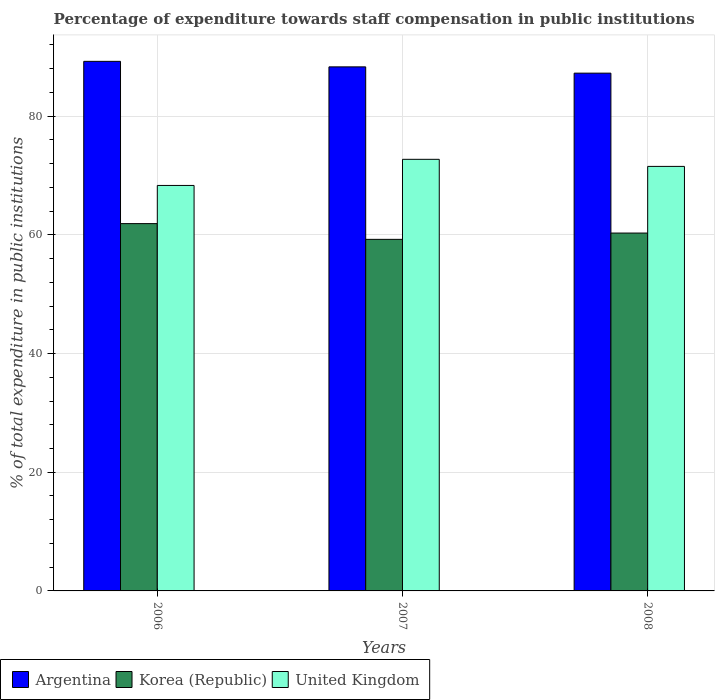Are the number of bars per tick equal to the number of legend labels?
Offer a very short reply. Yes. Are the number of bars on each tick of the X-axis equal?
Ensure brevity in your answer.  Yes. How many bars are there on the 3rd tick from the left?
Offer a terse response. 3. How many bars are there on the 2nd tick from the right?
Provide a succinct answer. 3. What is the label of the 1st group of bars from the left?
Provide a short and direct response. 2006. What is the percentage of expenditure towards staff compensation in Argentina in 2006?
Your response must be concise. 89.24. Across all years, what is the maximum percentage of expenditure towards staff compensation in United Kingdom?
Keep it short and to the point. 72.73. Across all years, what is the minimum percentage of expenditure towards staff compensation in Argentina?
Your answer should be very brief. 87.25. What is the total percentage of expenditure towards staff compensation in Argentina in the graph?
Your response must be concise. 264.81. What is the difference between the percentage of expenditure towards staff compensation in Argentina in 2006 and that in 2008?
Provide a short and direct response. 1.99. What is the difference between the percentage of expenditure towards staff compensation in United Kingdom in 2007 and the percentage of expenditure towards staff compensation in Argentina in 2006?
Provide a short and direct response. -16.51. What is the average percentage of expenditure towards staff compensation in United Kingdom per year?
Ensure brevity in your answer.  70.87. In the year 2006, what is the difference between the percentage of expenditure towards staff compensation in Argentina and percentage of expenditure towards staff compensation in United Kingdom?
Make the answer very short. 20.91. What is the ratio of the percentage of expenditure towards staff compensation in United Kingdom in 2007 to that in 2008?
Make the answer very short. 1.02. Is the percentage of expenditure towards staff compensation in United Kingdom in 2006 less than that in 2007?
Provide a succinct answer. Yes. Is the difference between the percentage of expenditure towards staff compensation in Argentina in 2006 and 2008 greater than the difference between the percentage of expenditure towards staff compensation in United Kingdom in 2006 and 2008?
Offer a very short reply. Yes. What is the difference between the highest and the second highest percentage of expenditure towards staff compensation in Argentina?
Make the answer very short. 0.93. What is the difference between the highest and the lowest percentage of expenditure towards staff compensation in United Kingdom?
Your answer should be very brief. 4.4. What does the 3rd bar from the left in 2007 represents?
Your answer should be compact. United Kingdom. What does the 3rd bar from the right in 2006 represents?
Ensure brevity in your answer.  Argentina. Is it the case that in every year, the sum of the percentage of expenditure towards staff compensation in Argentina and percentage of expenditure towards staff compensation in Korea (Republic) is greater than the percentage of expenditure towards staff compensation in United Kingdom?
Your response must be concise. Yes. How many bars are there?
Provide a short and direct response. 9. Are all the bars in the graph horizontal?
Your response must be concise. No. How many years are there in the graph?
Make the answer very short. 3. Are the values on the major ticks of Y-axis written in scientific E-notation?
Give a very brief answer. No. Does the graph contain any zero values?
Make the answer very short. No. How are the legend labels stacked?
Give a very brief answer. Horizontal. What is the title of the graph?
Offer a terse response. Percentage of expenditure towards staff compensation in public institutions. Does "Cabo Verde" appear as one of the legend labels in the graph?
Provide a succinct answer. No. What is the label or title of the Y-axis?
Your answer should be very brief. % of total expenditure in public institutions. What is the % of total expenditure in public institutions of Argentina in 2006?
Offer a very short reply. 89.24. What is the % of total expenditure in public institutions of Korea (Republic) in 2006?
Give a very brief answer. 61.9. What is the % of total expenditure in public institutions in United Kingdom in 2006?
Your response must be concise. 68.33. What is the % of total expenditure in public institutions of Argentina in 2007?
Offer a terse response. 88.31. What is the % of total expenditure in public institutions in Korea (Republic) in 2007?
Provide a succinct answer. 59.25. What is the % of total expenditure in public institutions in United Kingdom in 2007?
Ensure brevity in your answer.  72.73. What is the % of total expenditure in public institutions of Argentina in 2008?
Give a very brief answer. 87.25. What is the % of total expenditure in public institutions in Korea (Republic) in 2008?
Offer a terse response. 60.31. What is the % of total expenditure in public institutions of United Kingdom in 2008?
Ensure brevity in your answer.  71.54. Across all years, what is the maximum % of total expenditure in public institutions in Argentina?
Your answer should be compact. 89.24. Across all years, what is the maximum % of total expenditure in public institutions of Korea (Republic)?
Your response must be concise. 61.9. Across all years, what is the maximum % of total expenditure in public institutions of United Kingdom?
Give a very brief answer. 72.73. Across all years, what is the minimum % of total expenditure in public institutions in Argentina?
Offer a terse response. 87.25. Across all years, what is the minimum % of total expenditure in public institutions in Korea (Republic)?
Ensure brevity in your answer.  59.25. Across all years, what is the minimum % of total expenditure in public institutions in United Kingdom?
Your answer should be very brief. 68.33. What is the total % of total expenditure in public institutions in Argentina in the graph?
Make the answer very short. 264.81. What is the total % of total expenditure in public institutions of Korea (Republic) in the graph?
Keep it short and to the point. 181.45. What is the total % of total expenditure in public institutions in United Kingdom in the graph?
Make the answer very short. 212.6. What is the difference between the % of total expenditure in public institutions of Argentina in 2006 and that in 2007?
Ensure brevity in your answer.  0.93. What is the difference between the % of total expenditure in public institutions of Korea (Republic) in 2006 and that in 2007?
Keep it short and to the point. 2.65. What is the difference between the % of total expenditure in public institutions of United Kingdom in 2006 and that in 2007?
Keep it short and to the point. -4.4. What is the difference between the % of total expenditure in public institutions in Argentina in 2006 and that in 2008?
Give a very brief answer. 1.99. What is the difference between the % of total expenditure in public institutions of Korea (Republic) in 2006 and that in 2008?
Offer a terse response. 1.59. What is the difference between the % of total expenditure in public institutions of United Kingdom in 2006 and that in 2008?
Give a very brief answer. -3.21. What is the difference between the % of total expenditure in public institutions of Argentina in 2007 and that in 2008?
Your response must be concise. 1.06. What is the difference between the % of total expenditure in public institutions of Korea (Republic) in 2007 and that in 2008?
Provide a succinct answer. -1.06. What is the difference between the % of total expenditure in public institutions in United Kingdom in 2007 and that in 2008?
Give a very brief answer. 1.19. What is the difference between the % of total expenditure in public institutions in Argentina in 2006 and the % of total expenditure in public institutions in Korea (Republic) in 2007?
Your answer should be very brief. 30. What is the difference between the % of total expenditure in public institutions of Argentina in 2006 and the % of total expenditure in public institutions of United Kingdom in 2007?
Your answer should be compact. 16.51. What is the difference between the % of total expenditure in public institutions of Korea (Republic) in 2006 and the % of total expenditure in public institutions of United Kingdom in 2007?
Offer a terse response. -10.83. What is the difference between the % of total expenditure in public institutions of Argentina in 2006 and the % of total expenditure in public institutions of Korea (Republic) in 2008?
Keep it short and to the point. 28.93. What is the difference between the % of total expenditure in public institutions of Argentina in 2006 and the % of total expenditure in public institutions of United Kingdom in 2008?
Offer a very short reply. 17.7. What is the difference between the % of total expenditure in public institutions of Korea (Republic) in 2006 and the % of total expenditure in public institutions of United Kingdom in 2008?
Provide a short and direct response. -9.64. What is the difference between the % of total expenditure in public institutions of Argentina in 2007 and the % of total expenditure in public institutions of Korea (Republic) in 2008?
Keep it short and to the point. 28.01. What is the difference between the % of total expenditure in public institutions in Argentina in 2007 and the % of total expenditure in public institutions in United Kingdom in 2008?
Your answer should be very brief. 16.77. What is the difference between the % of total expenditure in public institutions in Korea (Republic) in 2007 and the % of total expenditure in public institutions in United Kingdom in 2008?
Make the answer very short. -12.3. What is the average % of total expenditure in public institutions of Argentina per year?
Your answer should be very brief. 88.27. What is the average % of total expenditure in public institutions of Korea (Republic) per year?
Provide a succinct answer. 60.48. What is the average % of total expenditure in public institutions in United Kingdom per year?
Ensure brevity in your answer.  70.87. In the year 2006, what is the difference between the % of total expenditure in public institutions in Argentina and % of total expenditure in public institutions in Korea (Republic)?
Give a very brief answer. 27.34. In the year 2006, what is the difference between the % of total expenditure in public institutions of Argentina and % of total expenditure in public institutions of United Kingdom?
Ensure brevity in your answer.  20.91. In the year 2006, what is the difference between the % of total expenditure in public institutions in Korea (Republic) and % of total expenditure in public institutions in United Kingdom?
Keep it short and to the point. -6.43. In the year 2007, what is the difference between the % of total expenditure in public institutions in Argentina and % of total expenditure in public institutions in Korea (Republic)?
Provide a succinct answer. 29.07. In the year 2007, what is the difference between the % of total expenditure in public institutions of Argentina and % of total expenditure in public institutions of United Kingdom?
Make the answer very short. 15.58. In the year 2007, what is the difference between the % of total expenditure in public institutions in Korea (Republic) and % of total expenditure in public institutions in United Kingdom?
Provide a succinct answer. -13.49. In the year 2008, what is the difference between the % of total expenditure in public institutions in Argentina and % of total expenditure in public institutions in Korea (Republic)?
Your response must be concise. 26.95. In the year 2008, what is the difference between the % of total expenditure in public institutions in Argentina and % of total expenditure in public institutions in United Kingdom?
Keep it short and to the point. 15.71. In the year 2008, what is the difference between the % of total expenditure in public institutions of Korea (Republic) and % of total expenditure in public institutions of United Kingdom?
Your answer should be very brief. -11.23. What is the ratio of the % of total expenditure in public institutions of Argentina in 2006 to that in 2007?
Provide a short and direct response. 1.01. What is the ratio of the % of total expenditure in public institutions in Korea (Republic) in 2006 to that in 2007?
Offer a terse response. 1.04. What is the ratio of the % of total expenditure in public institutions in United Kingdom in 2006 to that in 2007?
Provide a short and direct response. 0.94. What is the ratio of the % of total expenditure in public institutions in Argentina in 2006 to that in 2008?
Provide a short and direct response. 1.02. What is the ratio of the % of total expenditure in public institutions of Korea (Republic) in 2006 to that in 2008?
Provide a short and direct response. 1.03. What is the ratio of the % of total expenditure in public institutions in United Kingdom in 2006 to that in 2008?
Ensure brevity in your answer.  0.96. What is the ratio of the % of total expenditure in public institutions in Argentina in 2007 to that in 2008?
Give a very brief answer. 1.01. What is the ratio of the % of total expenditure in public institutions of Korea (Republic) in 2007 to that in 2008?
Provide a succinct answer. 0.98. What is the ratio of the % of total expenditure in public institutions in United Kingdom in 2007 to that in 2008?
Your answer should be compact. 1.02. What is the difference between the highest and the second highest % of total expenditure in public institutions in Argentina?
Ensure brevity in your answer.  0.93. What is the difference between the highest and the second highest % of total expenditure in public institutions of Korea (Republic)?
Provide a succinct answer. 1.59. What is the difference between the highest and the second highest % of total expenditure in public institutions of United Kingdom?
Offer a very short reply. 1.19. What is the difference between the highest and the lowest % of total expenditure in public institutions in Argentina?
Provide a succinct answer. 1.99. What is the difference between the highest and the lowest % of total expenditure in public institutions of Korea (Republic)?
Keep it short and to the point. 2.65. What is the difference between the highest and the lowest % of total expenditure in public institutions in United Kingdom?
Provide a short and direct response. 4.4. 